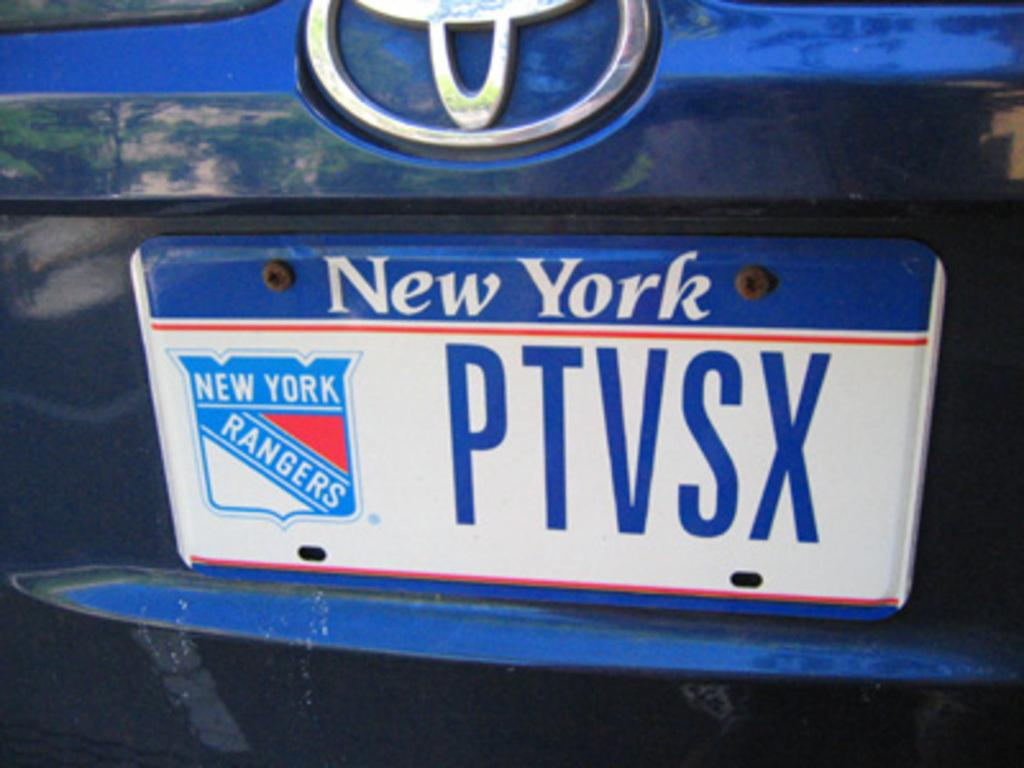<image>
Render a clear and concise summary of the photo. A New York license plate PTVSX with a New York Rangers logo on it is shown on the back of a blue car. 